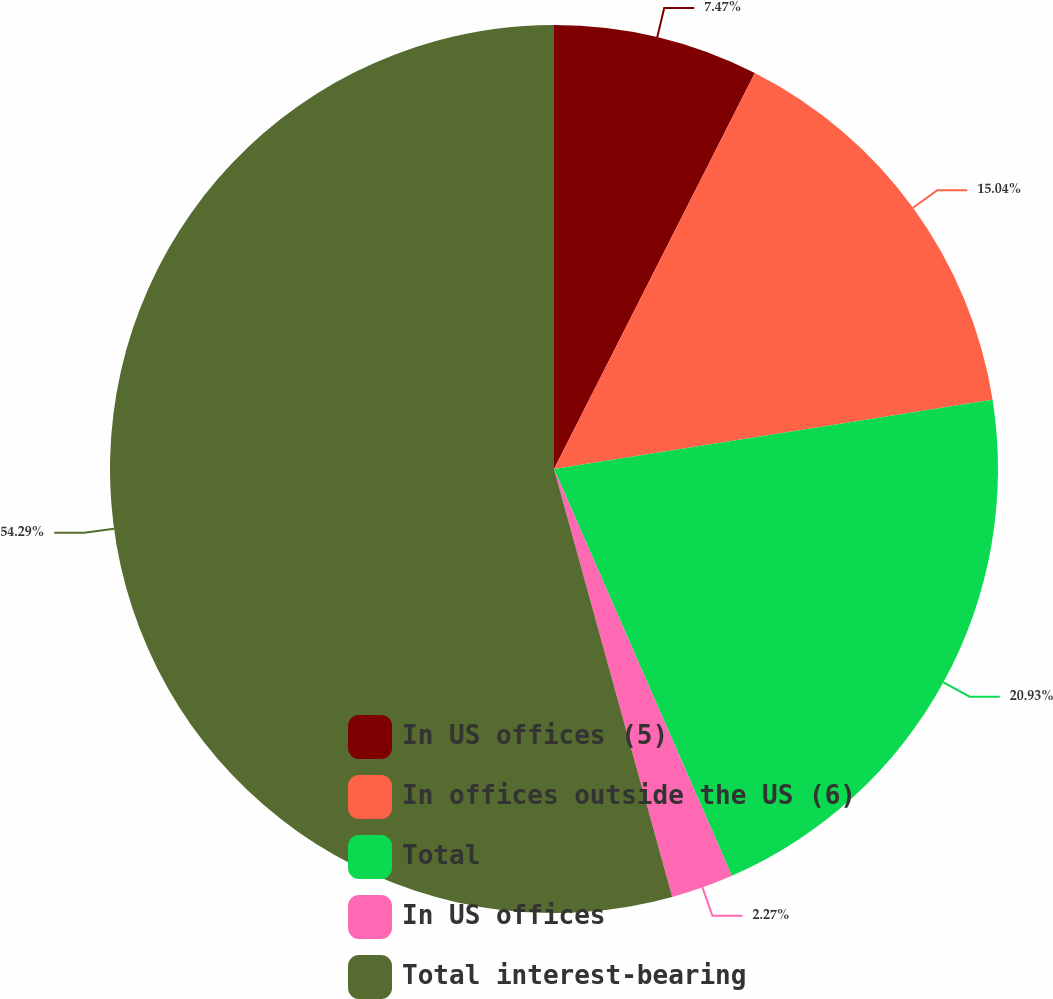Convert chart. <chart><loc_0><loc_0><loc_500><loc_500><pie_chart><fcel>In US offices (5)<fcel>In offices outside the US (6)<fcel>Total<fcel>In US offices<fcel>Total interest-bearing<nl><fcel>7.47%<fcel>15.04%<fcel>20.93%<fcel>2.27%<fcel>54.29%<nl></chart> 